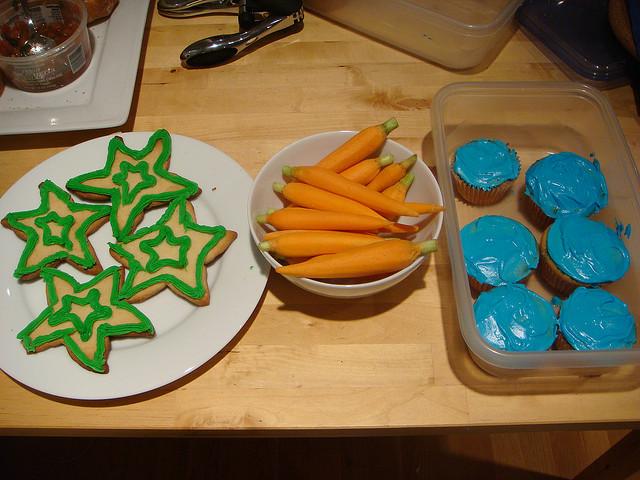What cookie is one the dessert?
Be succinct. Star. What color is the star?
Write a very short answer. Green. What letters are written on the cupcakes?
Quick response, please. None. What color icing do the cupcakes have?
Give a very brief answer. Blue. Are there any vegetables in this photo?
Quick response, please. Yes. What is in the middle dish?
Short answer required. Carrots. What color bowls are there?
Short answer required. White. What are the cupcakes made of?
Give a very brief answer. Cake mix. 